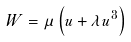Convert formula to latex. <formula><loc_0><loc_0><loc_500><loc_500>W = \mu \left ( u + \lambda u ^ { 3 } \right )</formula> 